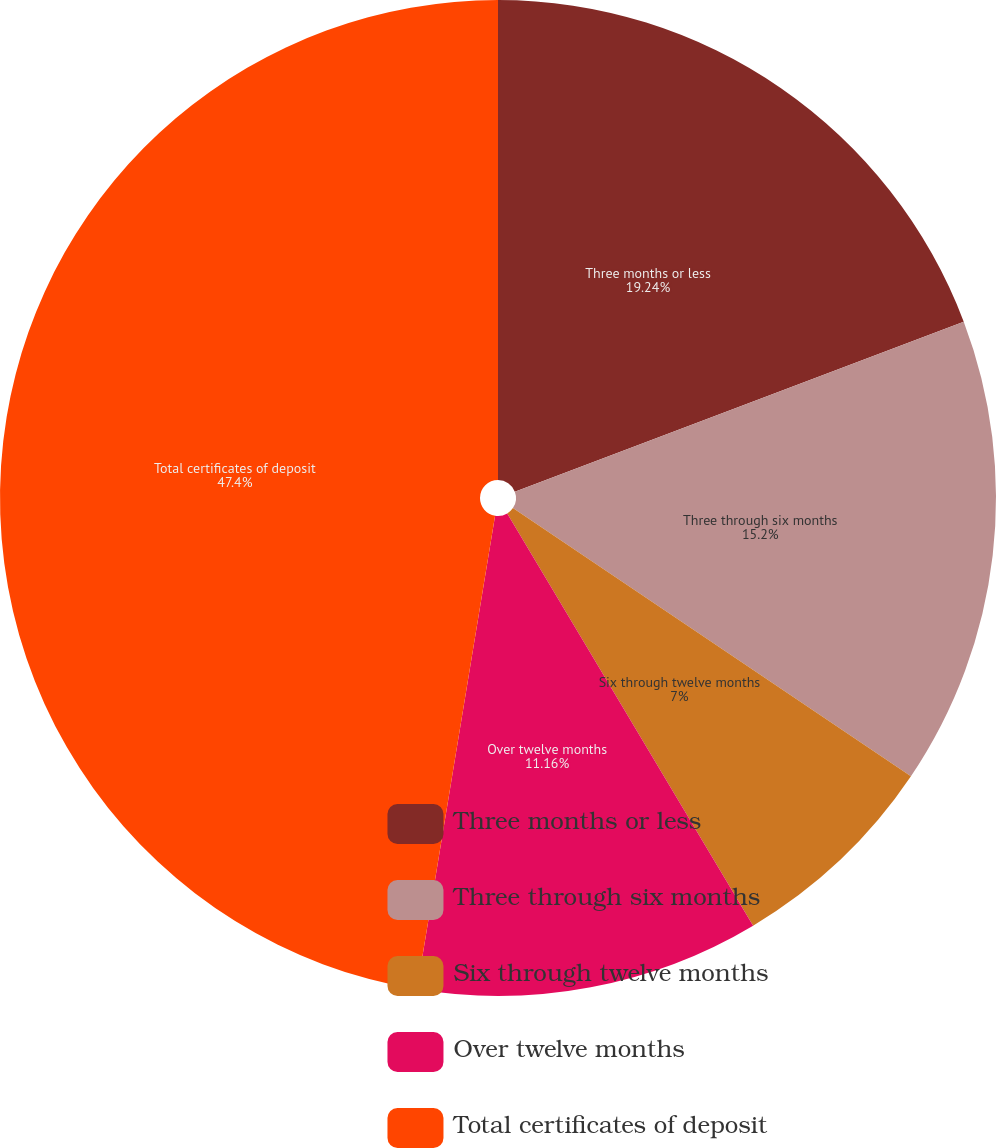Convert chart. <chart><loc_0><loc_0><loc_500><loc_500><pie_chart><fcel>Three months or less<fcel>Three through six months<fcel>Six through twelve months<fcel>Over twelve months<fcel>Total certificates of deposit<nl><fcel>19.24%<fcel>15.2%<fcel>7.0%<fcel>11.16%<fcel>47.4%<nl></chart> 